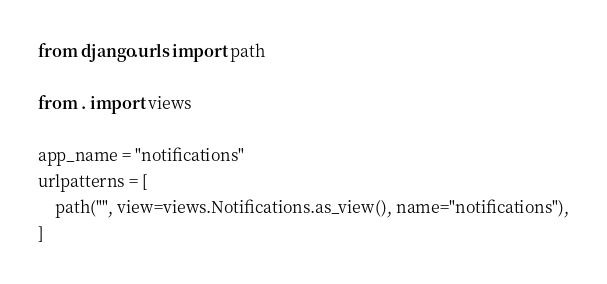Convert code to text. <code><loc_0><loc_0><loc_500><loc_500><_Python_>from django.urls import path

from . import views

app_name = "notifications"
urlpatterns = [
    path("", view=views.Notifications.as_view(), name="notifications"),
]</code> 